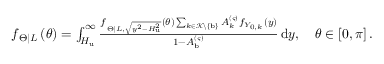Convert formula to latex. <formula><loc_0><loc_0><loc_500><loc_500>\begin{array} { r } { f _ { \Theta \right | L } \left ( \theta \right ) = \int _ { H _ { u } } ^ { \infty } { \frac { f _ { \Theta \right | L , \sqrt { y ^ { 2 } - H _ { u } ^ { 2 } } } \left ( \theta \right ) \sum _ { k \in \mathcal { K } \ \left \{ b \right \} } { A _ { k } ^ { \left ( \varsigma \right ) } f _ { Y _ { 0 , k } } \left ( y \right ) } } { 1 - A _ { b } ^ { \left ( \varsigma \right ) } } \, d y } , \quad \theta \in \left [ 0 , \pi \right ] . } \end{array}</formula> 